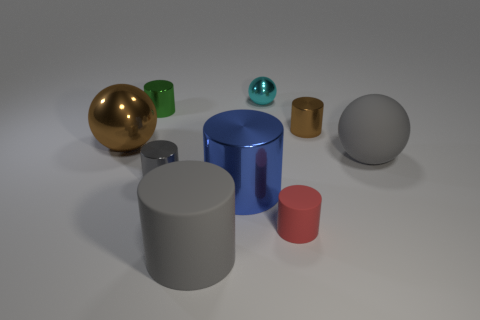Subtract all large blue metal cylinders. How many cylinders are left? 5 Subtract all brown cylinders. How many cylinders are left? 5 Subtract all red cubes. How many gray cylinders are left? 2 Subtract 1 spheres. How many spheres are left? 2 Subtract all cylinders. How many objects are left? 3 Subtract all blue objects. Subtract all large metal objects. How many objects are left? 6 Add 6 big gray spheres. How many big gray spheres are left? 7 Add 2 tiny metallic spheres. How many tiny metallic spheres exist? 3 Subtract 0 yellow cylinders. How many objects are left? 9 Subtract all brown spheres. Subtract all blue cylinders. How many spheres are left? 2 